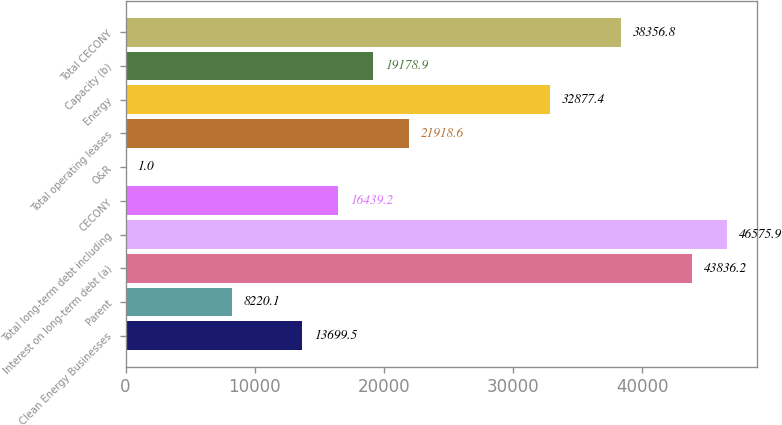Convert chart. <chart><loc_0><loc_0><loc_500><loc_500><bar_chart><fcel>Clean Energy Businesses<fcel>Parent<fcel>Interest on long-term debt (a)<fcel>Total long-term debt including<fcel>CECONY<fcel>O&R<fcel>Total operating leases<fcel>Energy<fcel>Capacity (b)<fcel>Total CECONY<nl><fcel>13699.5<fcel>8220.1<fcel>43836.2<fcel>46575.9<fcel>16439.2<fcel>1<fcel>21918.6<fcel>32877.4<fcel>19178.9<fcel>38356.8<nl></chart> 